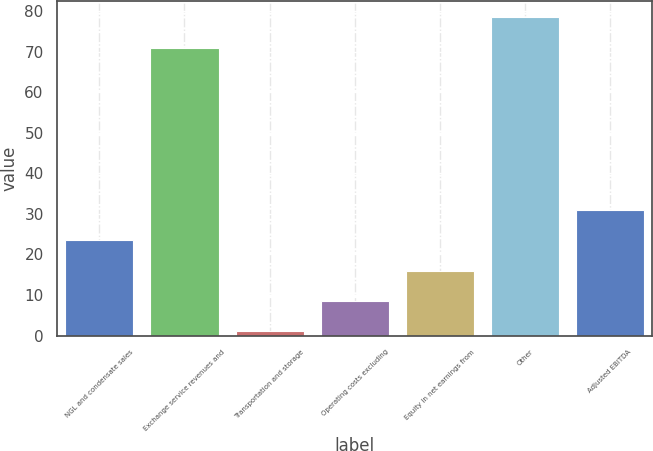Convert chart to OTSL. <chart><loc_0><loc_0><loc_500><loc_500><bar_chart><fcel>NGL and condensate sales<fcel>Exchange service revenues and<fcel>Transportation and storage<fcel>Operating costs excluding<fcel>Equity in net earnings from<fcel>Other<fcel>Adjusted EBITDA<nl><fcel>23.5<fcel>71<fcel>1<fcel>8.5<fcel>16<fcel>78.5<fcel>31<nl></chart> 